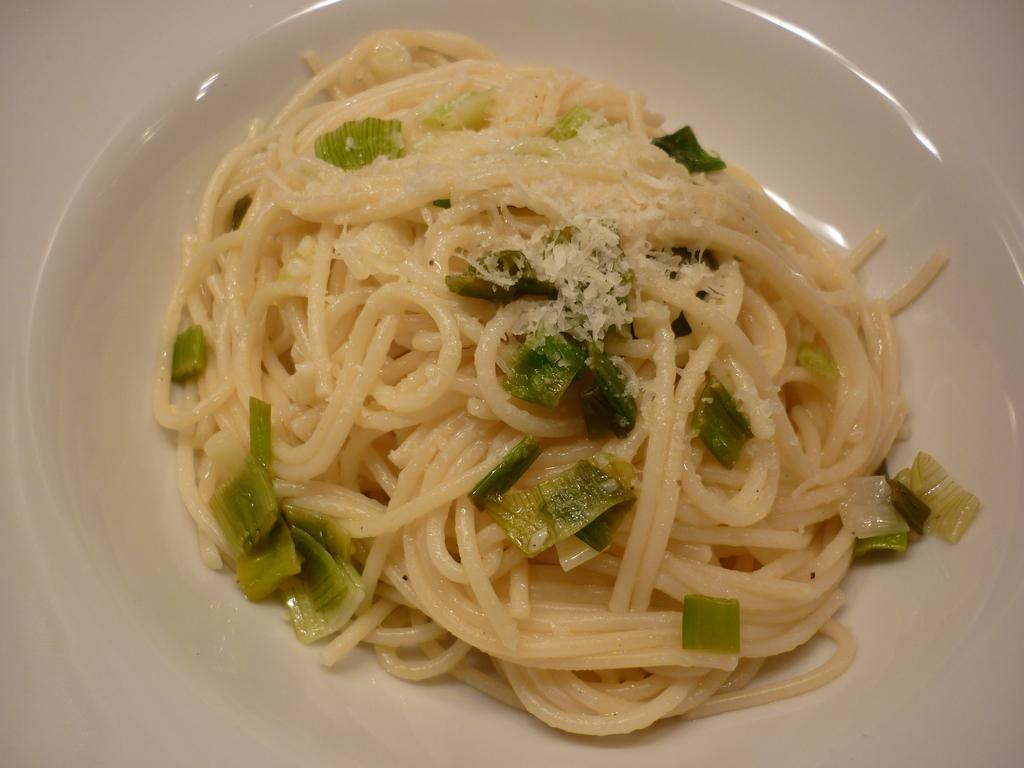What is the main subject of the image? There is a food item in the image. How is the food item presented? The food item is on a plate. What color are the objects at the edges of the image? The objects at the edges of the image are white. What is the aftermath of the food item being consumed? There is no indication of the food item being consumed in the image, so it's not possible to determine the aftermath. 